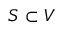Convert formula to latex. <formula><loc_0><loc_0><loc_500><loc_500>S \subset V</formula> 